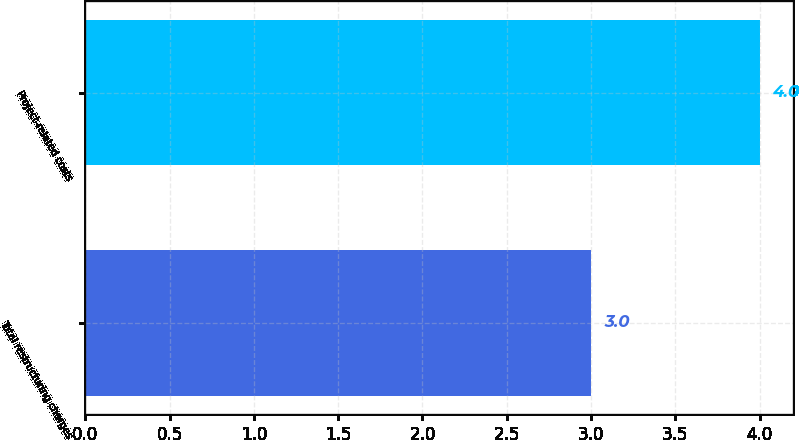Convert chart to OTSL. <chart><loc_0><loc_0><loc_500><loc_500><bar_chart><fcel>Total restructuring charges<fcel>Project-related costs<nl><fcel>3<fcel>4<nl></chart> 